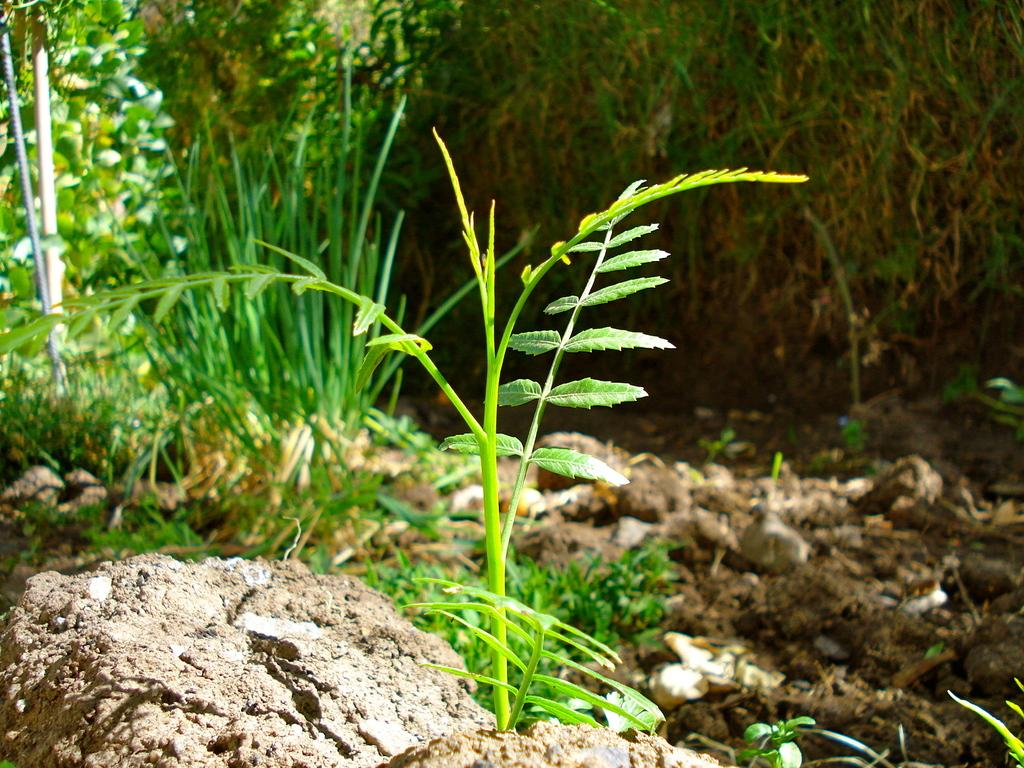What is the main subject in the center of the image? There is a plant in the center of the image. What type of vegetation can be seen in the background of the image? There is grass in the background of the image. What is the ground made of in the background of the image? Soil is visible in the background of the image. What time of day is depicted in the image, and what role does the drum play in this scene? There is no indication of time of day or any drum present in the image. 